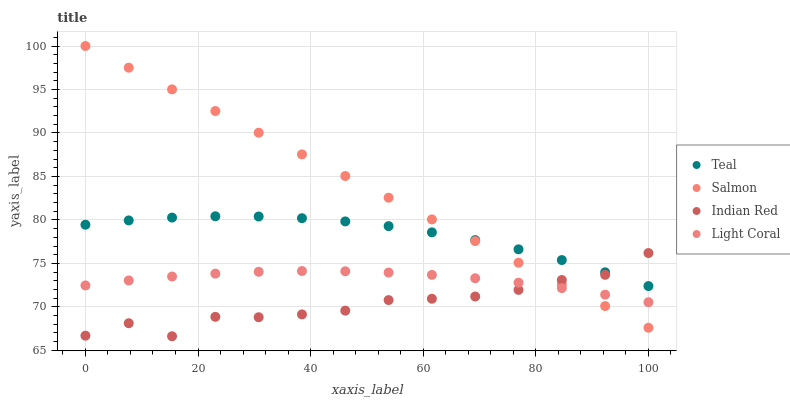Does Indian Red have the minimum area under the curve?
Answer yes or no. Yes. Does Salmon have the maximum area under the curve?
Answer yes or no. Yes. Does Salmon have the minimum area under the curve?
Answer yes or no. No. Does Indian Red have the maximum area under the curve?
Answer yes or no. No. Is Salmon the smoothest?
Answer yes or no. Yes. Is Indian Red the roughest?
Answer yes or no. Yes. Is Indian Red the smoothest?
Answer yes or no. No. Is Salmon the roughest?
Answer yes or no. No. Does Indian Red have the lowest value?
Answer yes or no. Yes. Does Salmon have the lowest value?
Answer yes or no. No. Does Salmon have the highest value?
Answer yes or no. Yes. Does Indian Red have the highest value?
Answer yes or no. No. Is Light Coral less than Teal?
Answer yes or no. Yes. Is Teal greater than Light Coral?
Answer yes or no. Yes. Does Salmon intersect Light Coral?
Answer yes or no. Yes. Is Salmon less than Light Coral?
Answer yes or no. No. Is Salmon greater than Light Coral?
Answer yes or no. No. Does Light Coral intersect Teal?
Answer yes or no. No. 